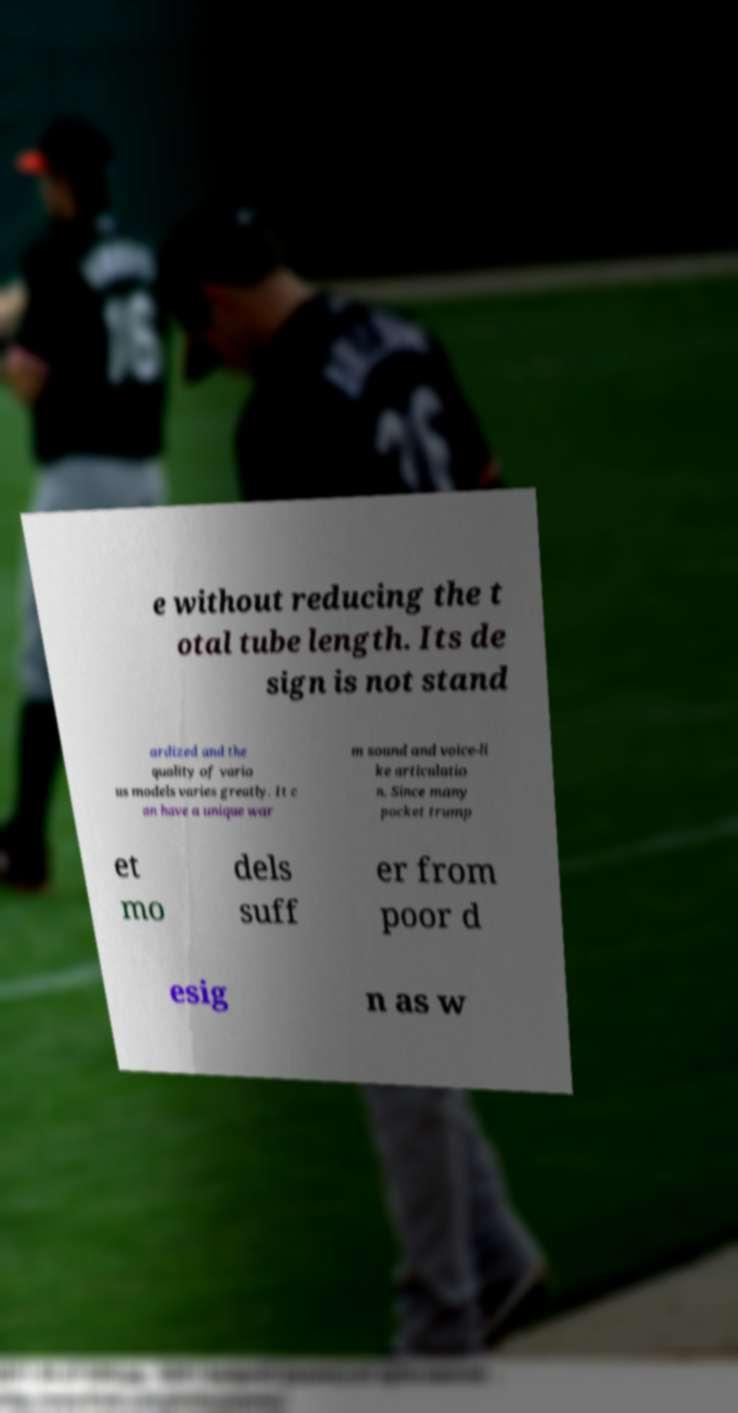Please read and relay the text visible in this image. What does it say? e without reducing the t otal tube length. Its de sign is not stand ardized and the quality of vario us models varies greatly. It c an have a unique war m sound and voice-li ke articulatio n. Since many pocket trump et mo dels suff er from poor d esig n as w 